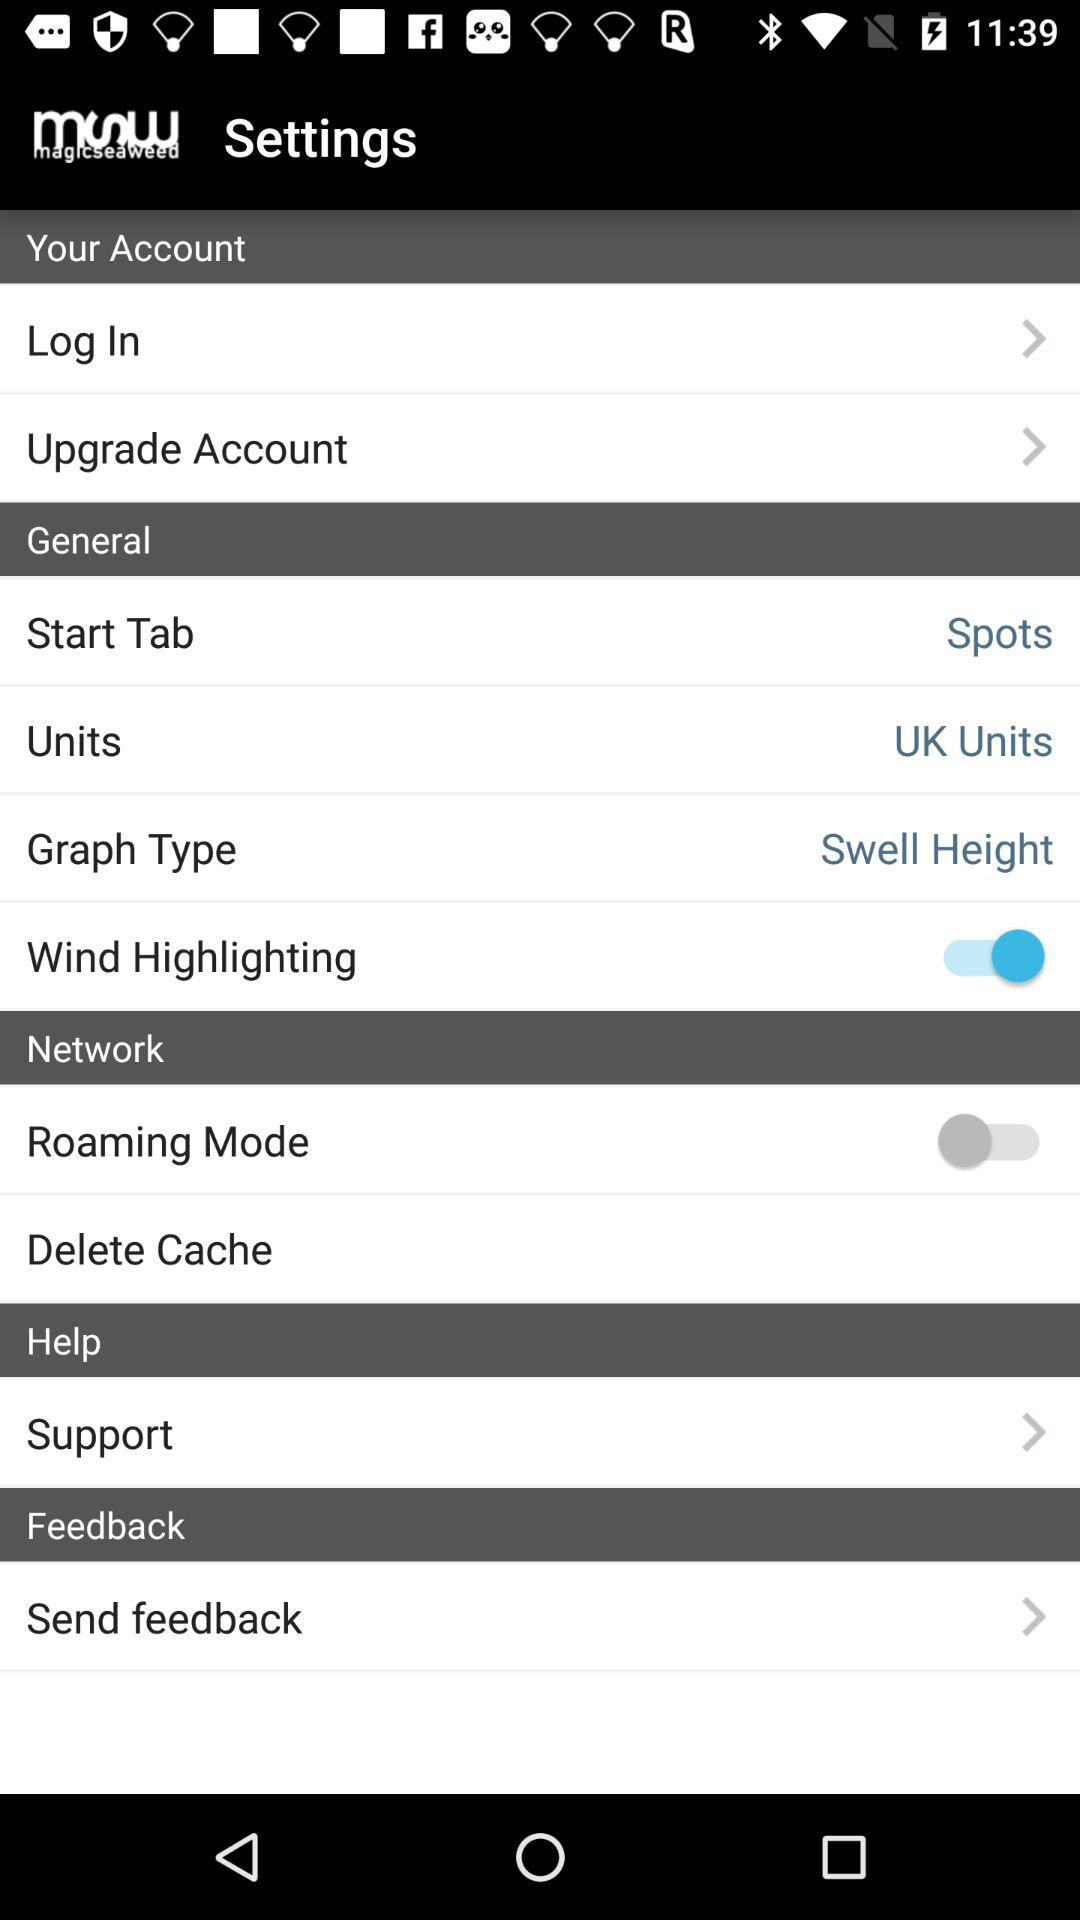What is the "Graph Type"? The "Graph Type" is "Swell Height". 